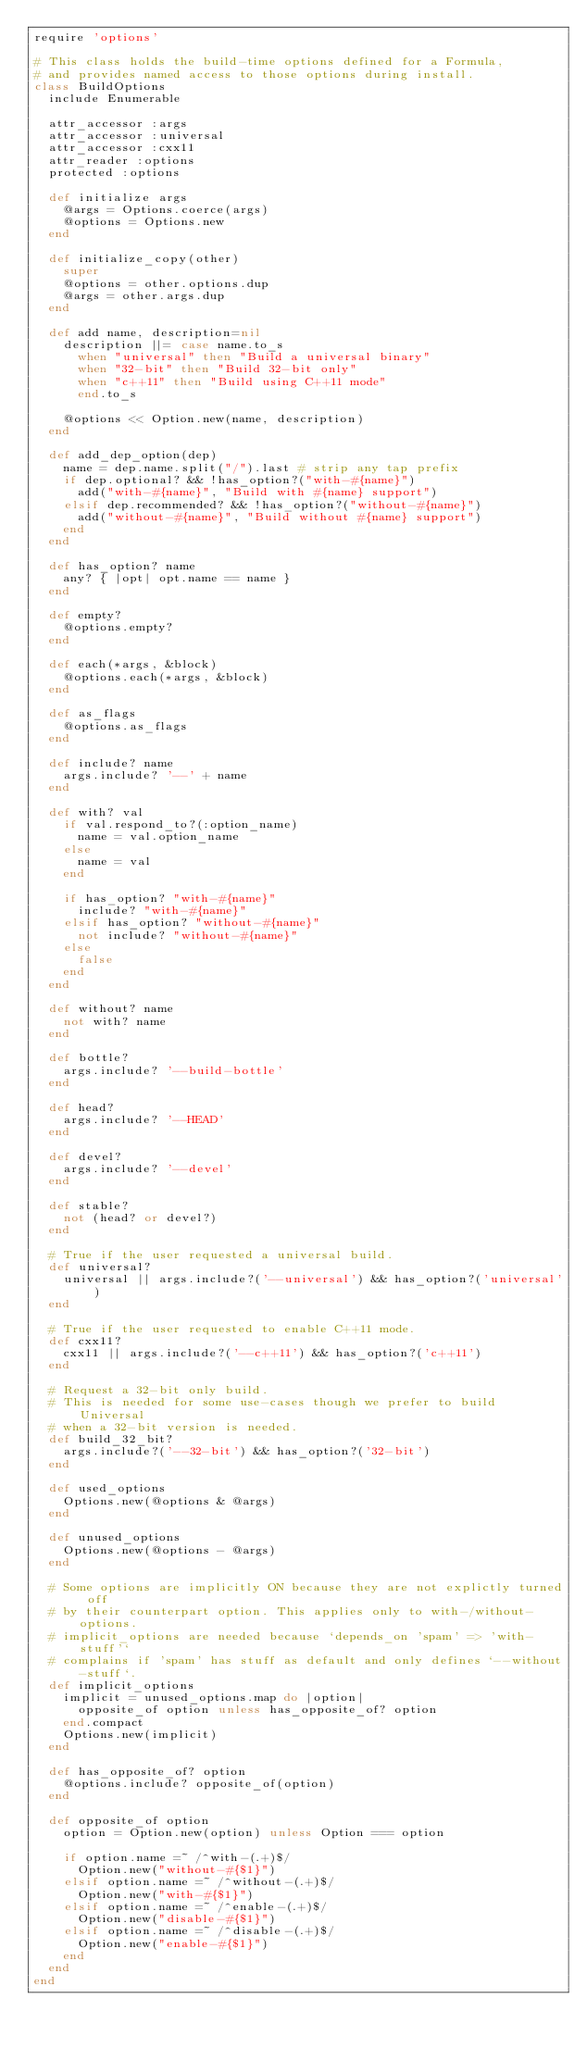Convert code to text. <code><loc_0><loc_0><loc_500><loc_500><_Ruby_>require 'options'

# This class holds the build-time options defined for a Formula,
# and provides named access to those options during install.
class BuildOptions
  include Enumerable

  attr_accessor :args
  attr_accessor :universal
  attr_accessor :cxx11
  attr_reader :options
  protected :options

  def initialize args
    @args = Options.coerce(args)
    @options = Options.new
  end

  def initialize_copy(other)
    super
    @options = other.options.dup
    @args = other.args.dup
  end

  def add name, description=nil
    description ||= case name.to_s
      when "universal" then "Build a universal binary"
      when "32-bit" then "Build 32-bit only"
      when "c++11" then "Build using C++11 mode"
      end.to_s

    @options << Option.new(name, description)
  end

  def add_dep_option(dep)
    name = dep.name.split("/").last # strip any tap prefix
    if dep.optional? && !has_option?("with-#{name}")
      add("with-#{name}", "Build with #{name} support")
    elsif dep.recommended? && !has_option?("without-#{name}")
      add("without-#{name}", "Build without #{name} support")
    end
  end

  def has_option? name
    any? { |opt| opt.name == name }
  end

  def empty?
    @options.empty?
  end

  def each(*args, &block)
    @options.each(*args, &block)
  end

  def as_flags
    @options.as_flags
  end

  def include? name
    args.include? '--' + name
  end

  def with? val
    if val.respond_to?(:option_name)
      name = val.option_name
    else
      name = val
    end

    if has_option? "with-#{name}"
      include? "with-#{name}"
    elsif has_option? "without-#{name}"
      not include? "without-#{name}"
    else
      false
    end
  end

  def without? name
    not with? name
  end

  def bottle?
    args.include? '--build-bottle'
  end

  def head?
    args.include? '--HEAD'
  end

  def devel?
    args.include? '--devel'
  end

  def stable?
    not (head? or devel?)
  end

  # True if the user requested a universal build.
  def universal?
    universal || args.include?('--universal') && has_option?('universal')
  end

  # True if the user requested to enable C++11 mode.
  def cxx11?
    cxx11 || args.include?('--c++11') && has_option?('c++11')
  end

  # Request a 32-bit only build.
  # This is needed for some use-cases though we prefer to build Universal
  # when a 32-bit version is needed.
  def build_32_bit?
    args.include?('--32-bit') && has_option?('32-bit')
  end

  def used_options
    Options.new(@options & @args)
  end

  def unused_options
    Options.new(@options - @args)
  end

  # Some options are implicitly ON because they are not explictly turned off
  # by their counterpart option. This applies only to with-/without- options.
  # implicit_options are needed because `depends_on 'spam' => 'with-stuff'`
  # complains if 'spam' has stuff as default and only defines `--without-stuff`.
  def implicit_options
    implicit = unused_options.map do |option|
      opposite_of option unless has_opposite_of? option
    end.compact
    Options.new(implicit)
  end

  def has_opposite_of? option
    @options.include? opposite_of(option)
  end

  def opposite_of option
    option = Option.new(option) unless Option === option

    if option.name =~ /^with-(.+)$/
      Option.new("without-#{$1}")
    elsif option.name =~ /^without-(.+)$/
      Option.new("with-#{$1}")
    elsif option.name =~ /^enable-(.+)$/
      Option.new("disable-#{$1}")
    elsif option.name =~ /^disable-(.+)$/
      Option.new("enable-#{$1}")
    end
  end
end
</code> 